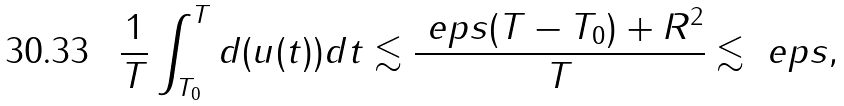Convert formula to latex. <formula><loc_0><loc_0><loc_500><loc_500>\frac { 1 } { T } \int _ { T _ { 0 } } ^ { T } d ( u ( t ) ) d t \lesssim \frac { \ e p s ( T - T _ { 0 } ) + R ^ { 2 } } { T } \lesssim \ e p s ,</formula> 